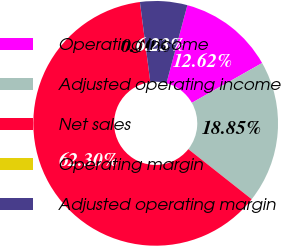<chart> <loc_0><loc_0><loc_500><loc_500><pie_chart><fcel>Operating income<fcel>Adjusted operating income<fcel>Net sales<fcel>Operating margin<fcel>Adjusted operating margin<nl><fcel>12.62%<fcel>18.85%<fcel>62.3%<fcel>0.0%<fcel>6.23%<nl></chart> 